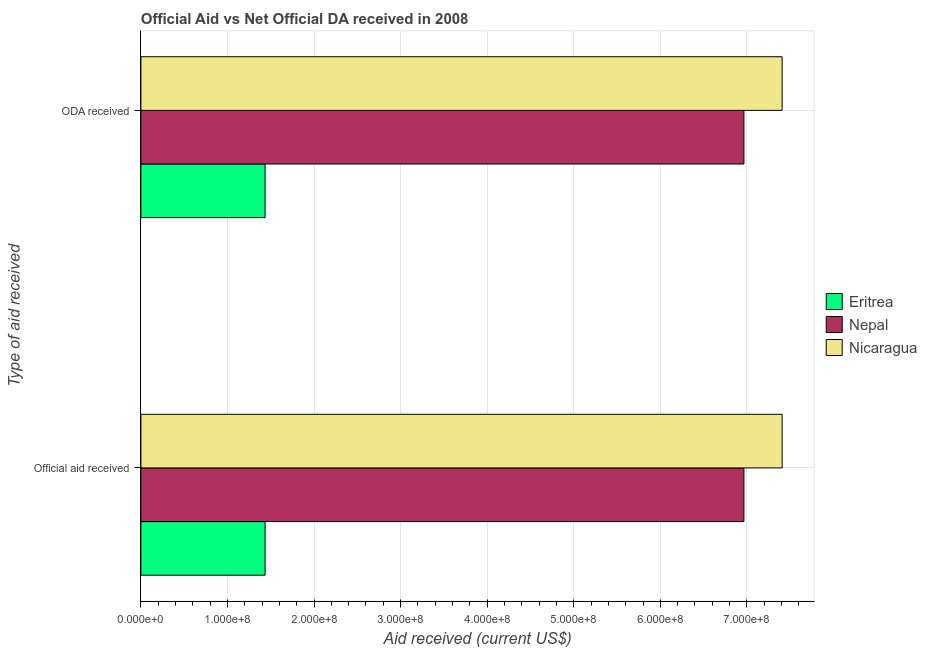How many groups of bars are there?
Provide a short and direct response. 2. Are the number of bars on each tick of the Y-axis equal?
Give a very brief answer. Yes. How many bars are there on the 1st tick from the top?
Provide a short and direct response. 3. What is the label of the 2nd group of bars from the top?
Provide a succinct answer. Official aid received. What is the official aid received in Nepal?
Give a very brief answer. 6.97e+08. Across all countries, what is the maximum official aid received?
Offer a terse response. 7.41e+08. Across all countries, what is the minimum official aid received?
Offer a very short reply. 1.43e+08. In which country was the oda received maximum?
Your answer should be compact. Nicaragua. In which country was the official aid received minimum?
Your answer should be very brief. Eritrea. What is the total oda received in the graph?
Provide a succinct answer. 1.58e+09. What is the difference between the official aid received in Nepal and that in Nicaragua?
Your answer should be compact. -4.42e+07. What is the difference between the official aid received in Nicaragua and the oda received in Eritrea?
Provide a succinct answer. 5.97e+08. What is the average oda received per country?
Provide a short and direct response. 5.27e+08. What is the difference between the oda received and official aid received in Nicaragua?
Offer a terse response. 0. What is the ratio of the oda received in Nicaragua to that in Eritrea?
Give a very brief answer. 5.16. In how many countries, is the oda received greater than the average oda received taken over all countries?
Provide a short and direct response. 2. What does the 3rd bar from the top in ODA received represents?
Provide a succinct answer. Eritrea. What does the 3rd bar from the bottom in Official aid received represents?
Provide a succinct answer. Nicaragua. How many bars are there?
Offer a terse response. 6. What is the difference between two consecutive major ticks on the X-axis?
Your answer should be very brief. 1.00e+08. Are the values on the major ticks of X-axis written in scientific E-notation?
Ensure brevity in your answer.  Yes. Does the graph contain any zero values?
Make the answer very short. No. What is the title of the graph?
Your answer should be very brief. Official Aid vs Net Official DA received in 2008 . What is the label or title of the X-axis?
Keep it short and to the point. Aid received (current US$). What is the label or title of the Y-axis?
Make the answer very short. Type of aid received. What is the Aid received (current US$) of Eritrea in Official aid received?
Offer a terse response. 1.43e+08. What is the Aid received (current US$) of Nepal in Official aid received?
Your response must be concise. 6.97e+08. What is the Aid received (current US$) in Nicaragua in Official aid received?
Offer a very short reply. 7.41e+08. What is the Aid received (current US$) of Eritrea in ODA received?
Your answer should be very brief. 1.43e+08. What is the Aid received (current US$) of Nepal in ODA received?
Keep it short and to the point. 6.97e+08. What is the Aid received (current US$) in Nicaragua in ODA received?
Offer a terse response. 7.41e+08. Across all Type of aid received, what is the maximum Aid received (current US$) in Eritrea?
Keep it short and to the point. 1.43e+08. Across all Type of aid received, what is the maximum Aid received (current US$) in Nepal?
Offer a terse response. 6.97e+08. Across all Type of aid received, what is the maximum Aid received (current US$) of Nicaragua?
Your response must be concise. 7.41e+08. Across all Type of aid received, what is the minimum Aid received (current US$) in Eritrea?
Ensure brevity in your answer.  1.43e+08. Across all Type of aid received, what is the minimum Aid received (current US$) of Nepal?
Offer a very short reply. 6.97e+08. Across all Type of aid received, what is the minimum Aid received (current US$) of Nicaragua?
Keep it short and to the point. 7.41e+08. What is the total Aid received (current US$) in Eritrea in the graph?
Provide a succinct answer. 2.87e+08. What is the total Aid received (current US$) of Nepal in the graph?
Give a very brief answer. 1.39e+09. What is the total Aid received (current US$) of Nicaragua in the graph?
Give a very brief answer. 1.48e+09. What is the difference between the Aid received (current US$) of Nicaragua in Official aid received and that in ODA received?
Ensure brevity in your answer.  0. What is the difference between the Aid received (current US$) in Eritrea in Official aid received and the Aid received (current US$) in Nepal in ODA received?
Your answer should be very brief. -5.53e+08. What is the difference between the Aid received (current US$) of Eritrea in Official aid received and the Aid received (current US$) of Nicaragua in ODA received?
Give a very brief answer. -5.97e+08. What is the difference between the Aid received (current US$) in Nepal in Official aid received and the Aid received (current US$) in Nicaragua in ODA received?
Ensure brevity in your answer.  -4.42e+07. What is the average Aid received (current US$) in Eritrea per Type of aid received?
Your answer should be very brief. 1.43e+08. What is the average Aid received (current US$) of Nepal per Type of aid received?
Ensure brevity in your answer.  6.97e+08. What is the average Aid received (current US$) of Nicaragua per Type of aid received?
Keep it short and to the point. 7.41e+08. What is the difference between the Aid received (current US$) of Eritrea and Aid received (current US$) of Nepal in Official aid received?
Your answer should be very brief. -5.53e+08. What is the difference between the Aid received (current US$) of Eritrea and Aid received (current US$) of Nicaragua in Official aid received?
Keep it short and to the point. -5.97e+08. What is the difference between the Aid received (current US$) in Nepal and Aid received (current US$) in Nicaragua in Official aid received?
Offer a very short reply. -4.42e+07. What is the difference between the Aid received (current US$) in Eritrea and Aid received (current US$) in Nepal in ODA received?
Offer a terse response. -5.53e+08. What is the difference between the Aid received (current US$) of Eritrea and Aid received (current US$) of Nicaragua in ODA received?
Your answer should be compact. -5.97e+08. What is the difference between the Aid received (current US$) of Nepal and Aid received (current US$) of Nicaragua in ODA received?
Offer a very short reply. -4.42e+07. What is the difference between the highest and the second highest Aid received (current US$) of Eritrea?
Offer a terse response. 0. What is the difference between the highest and the second highest Aid received (current US$) of Nicaragua?
Your answer should be very brief. 0. What is the difference between the highest and the lowest Aid received (current US$) of Nicaragua?
Your answer should be very brief. 0. 